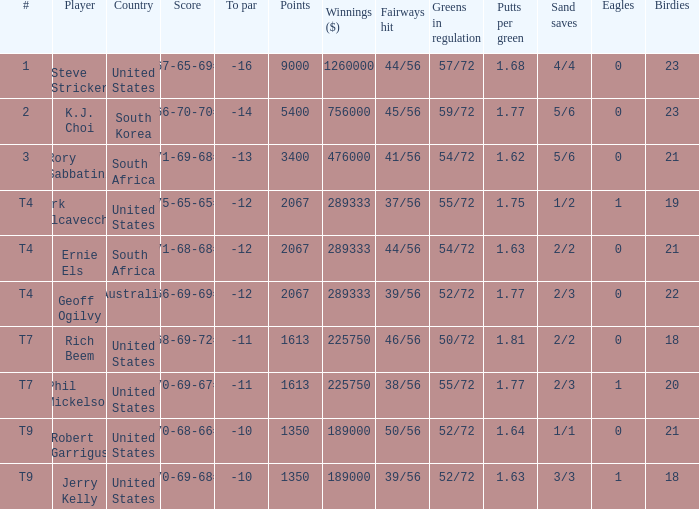Name the number of points for south korea 1.0. 